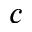Convert formula to latex. <formula><loc_0><loc_0><loc_500><loc_500>c</formula> 